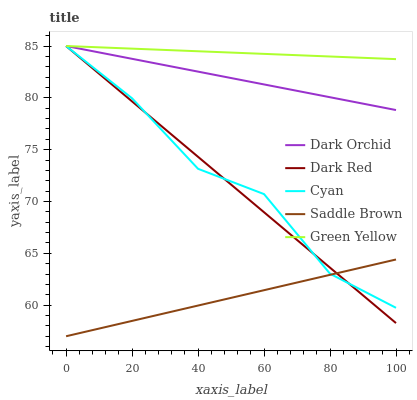Does Saddle Brown have the minimum area under the curve?
Answer yes or no. Yes. Does Green Yellow have the maximum area under the curve?
Answer yes or no. Yes. Does Green Yellow have the minimum area under the curve?
Answer yes or no. No. Does Saddle Brown have the maximum area under the curve?
Answer yes or no. No. Is Saddle Brown the smoothest?
Answer yes or no. Yes. Is Cyan the roughest?
Answer yes or no. Yes. Is Green Yellow the smoothest?
Answer yes or no. No. Is Green Yellow the roughest?
Answer yes or no. No. Does Saddle Brown have the lowest value?
Answer yes or no. Yes. Does Green Yellow have the lowest value?
Answer yes or no. No. Does Cyan have the highest value?
Answer yes or no. Yes. Does Saddle Brown have the highest value?
Answer yes or no. No. Is Saddle Brown less than Green Yellow?
Answer yes or no. Yes. Is Green Yellow greater than Saddle Brown?
Answer yes or no. Yes. Does Dark Orchid intersect Green Yellow?
Answer yes or no. Yes. Is Dark Orchid less than Green Yellow?
Answer yes or no. No. Is Dark Orchid greater than Green Yellow?
Answer yes or no. No. Does Saddle Brown intersect Green Yellow?
Answer yes or no. No. 